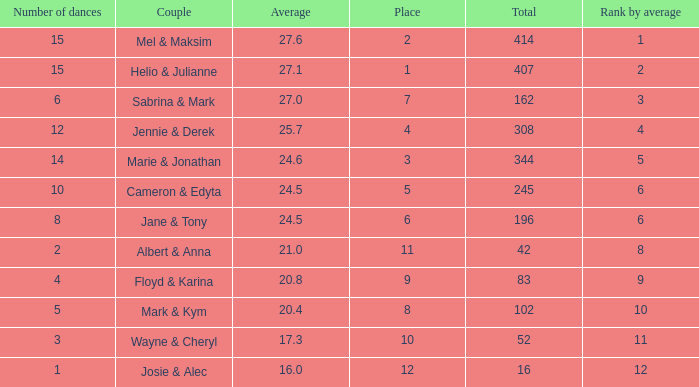What is the smallest place number when the total is 16 and average is less than 16? None. 